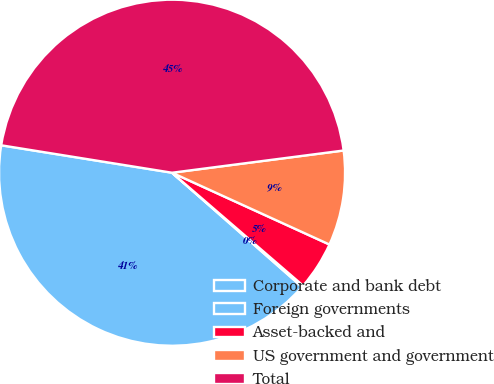Convert chart. <chart><loc_0><loc_0><loc_500><loc_500><pie_chart><fcel>Corporate and bank debt<fcel>Foreign governments<fcel>Asset-backed and<fcel>US government and government<fcel>Total<nl><fcel>41.06%<fcel>0.15%<fcel>4.51%<fcel>8.86%<fcel>45.41%<nl></chart> 